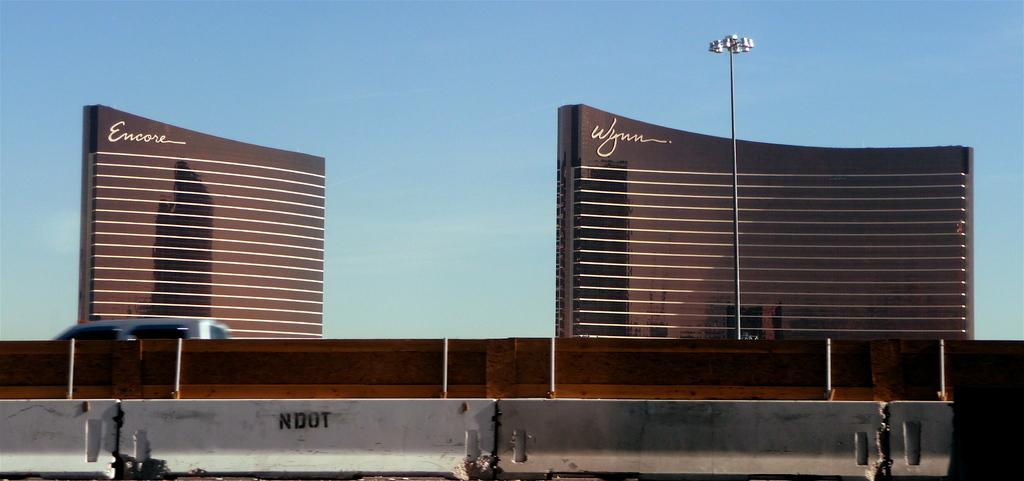What type of structures can be seen in the image? There are buildings in the image. What else is present in the image besides the buildings? There is a vehicle, a wall, lights on a pole, and jersey barriers at the bottom of the image. Can you describe the lighting in the image? There are lights on a pole in the image. What is visible in the background of the image? The sky is visible in the background of the image. How many bubbles can be seen floating in the image? There are no bubbles present in the image. What letter is written on the side of the vehicle in the image? There is no letter written on the side of the vehicle in the image. 